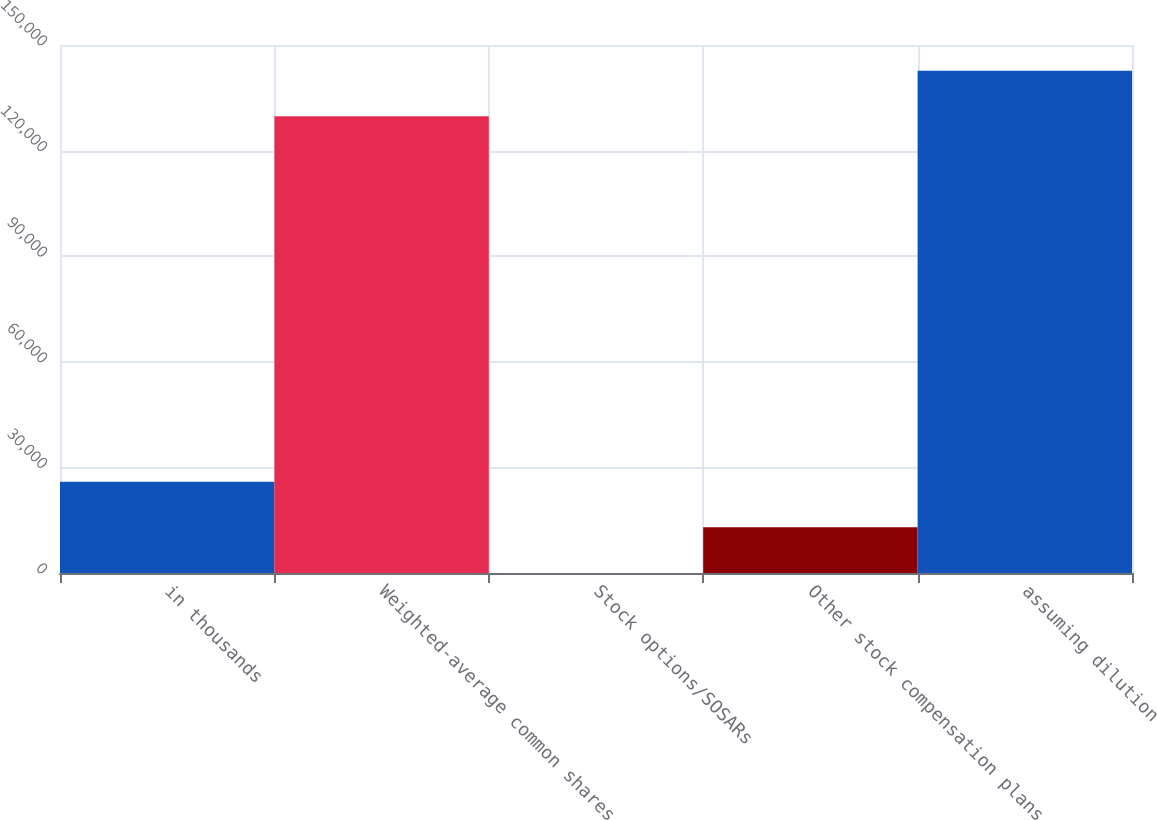<chart> <loc_0><loc_0><loc_500><loc_500><bar_chart><fcel>in thousands<fcel>Weighted-average common shares<fcel>Stock options/SOSARs<fcel>Other stock compensation plans<fcel>assuming dilution<nl><fcel>25949.7<fcel>129745<fcel>0.81<fcel>12975.2<fcel>142719<nl></chart> 